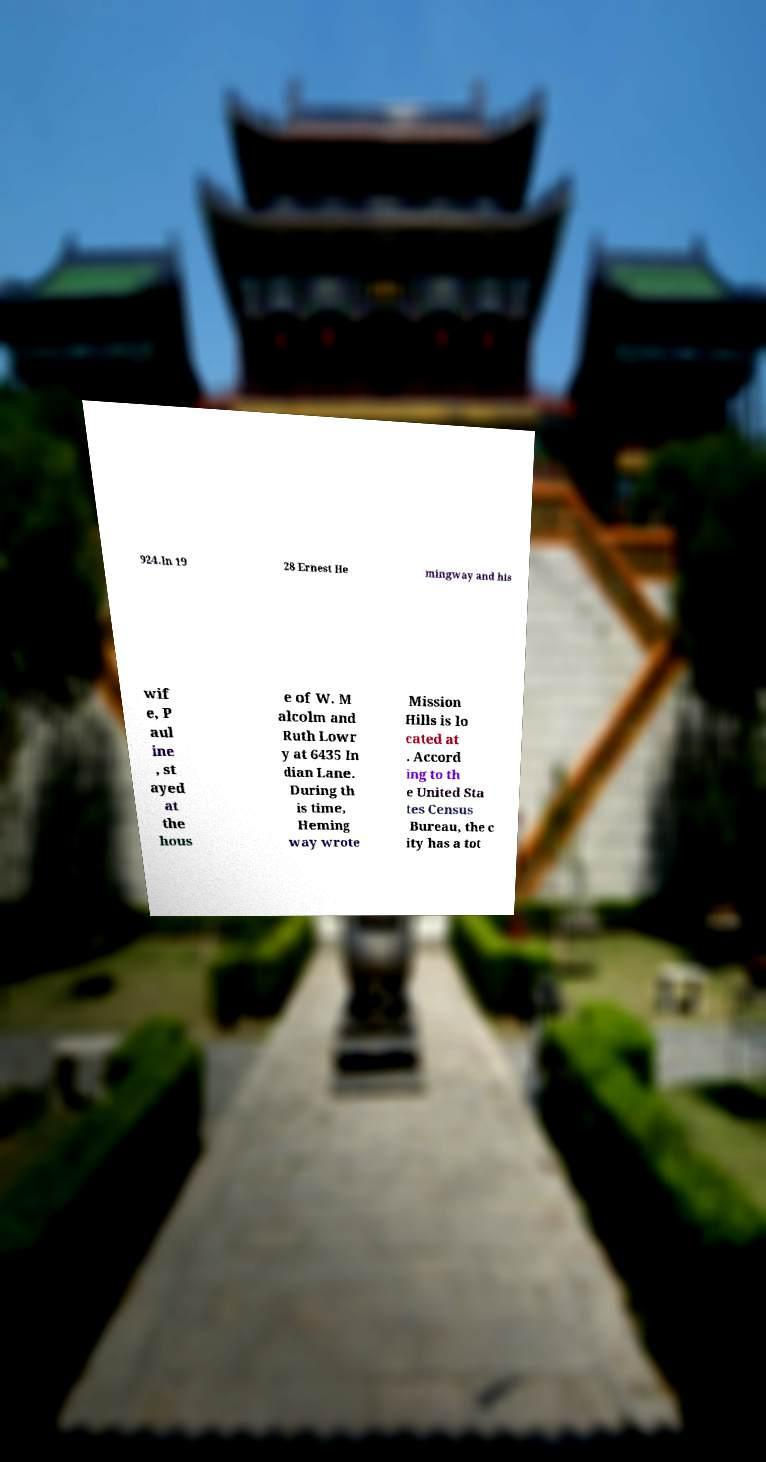What messages or text are displayed in this image? I need them in a readable, typed format. 924.In 19 28 Ernest He mingway and his wif e, P aul ine , st ayed at the hous e of W. M alcolm and Ruth Lowr y at 6435 In dian Lane. During th is time, Heming way wrote Mission Hills is lo cated at . Accord ing to th e United Sta tes Census Bureau, the c ity has a tot 